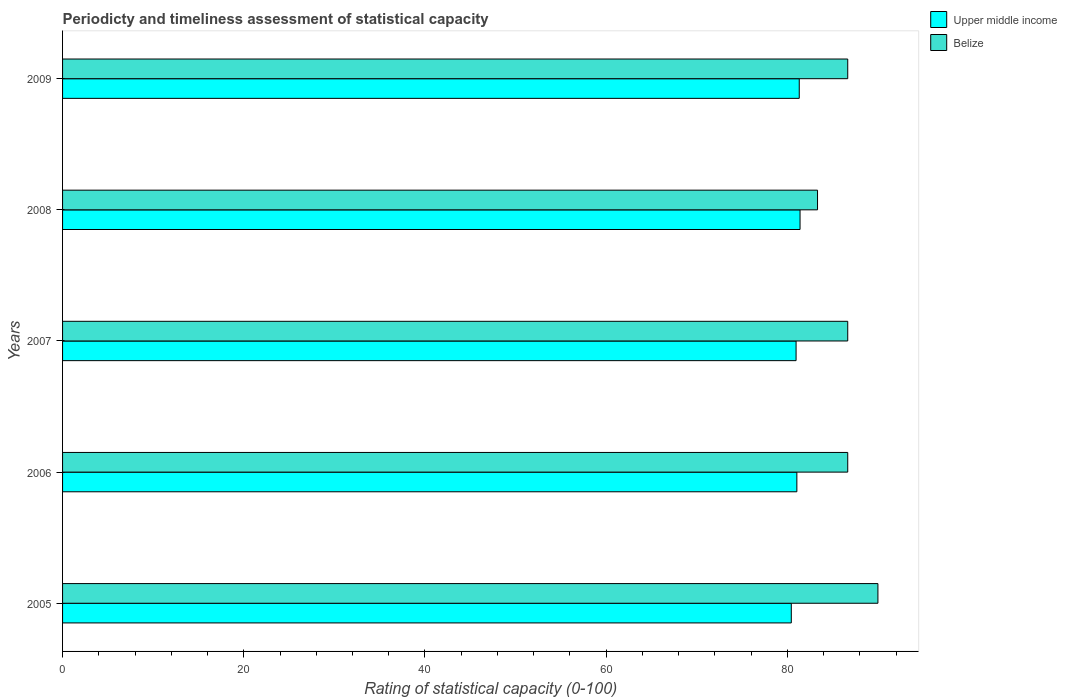How many different coloured bars are there?
Provide a succinct answer. 2. Are the number of bars per tick equal to the number of legend labels?
Offer a terse response. Yes. What is the rating of statistical capacity in Belize in 2009?
Make the answer very short. 86.67. Across all years, what is the minimum rating of statistical capacity in Belize?
Keep it short and to the point. 83.33. In which year was the rating of statistical capacity in Upper middle income maximum?
Provide a short and direct response. 2008. In which year was the rating of statistical capacity in Belize minimum?
Your response must be concise. 2008. What is the total rating of statistical capacity in Belize in the graph?
Ensure brevity in your answer.  433.33. What is the difference between the rating of statistical capacity in Belize in 2008 and that in 2009?
Your answer should be compact. -3.33. What is the difference between the rating of statistical capacity in Belize in 2005 and the rating of statistical capacity in Upper middle income in 2008?
Provide a succinct answer. 8.6. What is the average rating of statistical capacity in Upper middle income per year?
Make the answer very short. 81.03. In the year 2006, what is the difference between the rating of statistical capacity in Belize and rating of statistical capacity in Upper middle income?
Give a very brief answer. 5.61. What is the ratio of the rating of statistical capacity in Upper middle income in 2005 to that in 2006?
Provide a succinct answer. 0.99. Is the rating of statistical capacity in Upper middle income in 2005 less than that in 2007?
Provide a short and direct response. Yes. What is the difference between the highest and the second highest rating of statistical capacity in Belize?
Your response must be concise. 3.33. What is the difference between the highest and the lowest rating of statistical capacity in Belize?
Offer a terse response. 6.67. In how many years, is the rating of statistical capacity in Upper middle income greater than the average rating of statistical capacity in Upper middle income taken over all years?
Offer a very short reply. 3. Is the sum of the rating of statistical capacity in Upper middle income in 2007 and 2008 greater than the maximum rating of statistical capacity in Belize across all years?
Keep it short and to the point. Yes. What does the 1st bar from the top in 2008 represents?
Offer a very short reply. Belize. What does the 1st bar from the bottom in 2009 represents?
Provide a succinct answer. Upper middle income. How many years are there in the graph?
Offer a very short reply. 5. What is the difference between two consecutive major ticks on the X-axis?
Your response must be concise. 20. Are the values on the major ticks of X-axis written in scientific E-notation?
Offer a terse response. No. How many legend labels are there?
Keep it short and to the point. 2. How are the legend labels stacked?
Make the answer very short. Vertical. What is the title of the graph?
Give a very brief answer. Periodicty and timeliness assessment of statistical capacity. Does "St. Martin (French part)" appear as one of the legend labels in the graph?
Offer a very short reply. No. What is the label or title of the X-axis?
Your answer should be compact. Rating of statistical capacity (0-100). What is the label or title of the Y-axis?
Offer a terse response. Years. What is the Rating of statistical capacity (0-100) of Upper middle income in 2005?
Provide a short and direct response. 80.44. What is the Rating of statistical capacity (0-100) in Belize in 2005?
Offer a very short reply. 90. What is the Rating of statistical capacity (0-100) of Upper middle income in 2006?
Ensure brevity in your answer.  81.05. What is the Rating of statistical capacity (0-100) of Belize in 2006?
Your response must be concise. 86.67. What is the Rating of statistical capacity (0-100) of Upper middle income in 2007?
Offer a very short reply. 80.96. What is the Rating of statistical capacity (0-100) of Belize in 2007?
Offer a very short reply. 86.67. What is the Rating of statistical capacity (0-100) of Upper middle income in 2008?
Give a very brief answer. 81.4. What is the Rating of statistical capacity (0-100) of Belize in 2008?
Provide a short and direct response. 83.33. What is the Rating of statistical capacity (0-100) in Upper middle income in 2009?
Offer a terse response. 81.32. What is the Rating of statistical capacity (0-100) in Belize in 2009?
Make the answer very short. 86.67. Across all years, what is the maximum Rating of statistical capacity (0-100) of Upper middle income?
Ensure brevity in your answer.  81.4. Across all years, what is the maximum Rating of statistical capacity (0-100) of Belize?
Provide a succinct answer. 90. Across all years, what is the minimum Rating of statistical capacity (0-100) of Upper middle income?
Your answer should be compact. 80.44. Across all years, what is the minimum Rating of statistical capacity (0-100) of Belize?
Keep it short and to the point. 83.33. What is the total Rating of statistical capacity (0-100) in Upper middle income in the graph?
Your response must be concise. 405.17. What is the total Rating of statistical capacity (0-100) of Belize in the graph?
Your answer should be compact. 433.33. What is the difference between the Rating of statistical capacity (0-100) of Upper middle income in 2005 and that in 2006?
Keep it short and to the point. -0.61. What is the difference between the Rating of statistical capacity (0-100) in Belize in 2005 and that in 2006?
Provide a succinct answer. 3.33. What is the difference between the Rating of statistical capacity (0-100) of Upper middle income in 2005 and that in 2007?
Ensure brevity in your answer.  -0.53. What is the difference between the Rating of statistical capacity (0-100) in Belize in 2005 and that in 2007?
Your answer should be very brief. 3.33. What is the difference between the Rating of statistical capacity (0-100) of Upper middle income in 2005 and that in 2008?
Offer a very short reply. -0.96. What is the difference between the Rating of statistical capacity (0-100) of Upper middle income in 2005 and that in 2009?
Ensure brevity in your answer.  -0.88. What is the difference between the Rating of statistical capacity (0-100) of Upper middle income in 2006 and that in 2007?
Give a very brief answer. 0.09. What is the difference between the Rating of statistical capacity (0-100) of Upper middle income in 2006 and that in 2008?
Your answer should be very brief. -0.35. What is the difference between the Rating of statistical capacity (0-100) of Upper middle income in 2006 and that in 2009?
Provide a short and direct response. -0.26. What is the difference between the Rating of statistical capacity (0-100) of Belize in 2006 and that in 2009?
Keep it short and to the point. 0. What is the difference between the Rating of statistical capacity (0-100) in Upper middle income in 2007 and that in 2008?
Provide a short and direct response. -0.44. What is the difference between the Rating of statistical capacity (0-100) of Upper middle income in 2007 and that in 2009?
Provide a succinct answer. -0.35. What is the difference between the Rating of statistical capacity (0-100) of Belize in 2007 and that in 2009?
Your response must be concise. 0. What is the difference between the Rating of statistical capacity (0-100) in Upper middle income in 2008 and that in 2009?
Your answer should be compact. 0.09. What is the difference between the Rating of statistical capacity (0-100) of Belize in 2008 and that in 2009?
Offer a terse response. -3.33. What is the difference between the Rating of statistical capacity (0-100) of Upper middle income in 2005 and the Rating of statistical capacity (0-100) of Belize in 2006?
Provide a succinct answer. -6.23. What is the difference between the Rating of statistical capacity (0-100) in Upper middle income in 2005 and the Rating of statistical capacity (0-100) in Belize in 2007?
Provide a short and direct response. -6.23. What is the difference between the Rating of statistical capacity (0-100) in Upper middle income in 2005 and the Rating of statistical capacity (0-100) in Belize in 2008?
Provide a succinct answer. -2.89. What is the difference between the Rating of statistical capacity (0-100) in Upper middle income in 2005 and the Rating of statistical capacity (0-100) in Belize in 2009?
Offer a terse response. -6.23. What is the difference between the Rating of statistical capacity (0-100) of Upper middle income in 2006 and the Rating of statistical capacity (0-100) of Belize in 2007?
Give a very brief answer. -5.61. What is the difference between the Rating of statistical capacity (0-100) in Upper middle income in 2006 and the Rating of statistical capacity (0-100) in Belize in 2008?
Provide a short and direct response. -2.28. What is the difference between the Rating of statistical capacity (0-100) of Upper middle income in 2006 and the Rating of statistical capacity (0-100) of Belize in 2009?
Offer a terse response. -5.61. What is the difference between the Rating of statistical capacity (0-100) in Upper middle income in 2007 and the Rating of statistical capacity (0-100) in Belize in 2008?
Provide a short and direct response. -2.37. What is the difference between the Rating of statistical capacity (0-100) in Upper middle income in 2007 and the Rating of statistical capacity (0-100) in Belize in 2009?
Your answer should be very brief. -5.7. What is the difference between the Rating of statistical capacity (0-100) of Upper middle income in 2008 and the Rating of statistical capacity (0-100) of Belize in 2009?
Make the answer very short. -5.26. What is the average Rating of statistical capacity (0-100) of Upper middle income per year?
Offer a terse response. 81.03. What is the average Rating of statistical capacity (0-100) in Belize per year?
Ensure brevity in your answer.  86.67. In the year 2005, what is the difference between the Rating of statistical capacity (0-100) in Upper middle income and Rating of statistical capacity (0-100) in Belize?
Your answer should be very brief. -9.56. In the year 2006, what is the difference between the Rating of statistical capacity (0-100) of Upper middle income and Rating of statistical capacity (0-100) of Belize?
Offer a very short reply. -5.61. In the year 2007, what is the difference between the Rating of statistical capacity (0-100) in Upper middle income and Rating of statistical capacity (0-100) in Belize?
Ensure brevity in your answer.  -5.7. In the year 2008, what is the difference between the Rating of statistical capacity (0-100) of Upper middle income and Rating of statistical capacity (0-100) of Belize?
Make the answer very short. -1.93. In the year 2009, what is the difference between the Rating of statistical capacity (0-100) of Upper middle income and Rating of statistical capacity (0-100) of Belize?
Ensure brevity in your answer.  -5.35. What is the ratio of the Rating of statistical capacity (0-100) in Upper middle income in 2005 to that in 2007?
Offer a terse response. 0.99. What is the ratio of the Rating of statistical capacity (0-100) of Upper middle income in 2005 to that in 2008?
Keep it short and to the point. 0.99. What is the ratio of the Rating of statistical capacity (0-100) in Belize in 2005 to that in 2009?
Offer a terse response. 1.04. What is the ratio of the Rating of statistical capacity (0-100) of Belize in 2006 to that in 2008?
Ensure brevity in your answer.  1.04. What is the ratio of the Rating of statistical capacity (0-100) of Upper middle income in 2006 to that in 2009?
Give a very brief answer. 1. What is the ratio of the Rating of statistical capacity (0-100) in Upper middle income in 2007 to that in 2008?
Offer a terse response. 0.99. What is the ratio of the Rating of statistical capacity (0-100) in Upper middle income in 2007 to that in 2009?
Give a very brief answer. 1. What is the ratio of the Rating of statistical capacity (0-100) in Belize in 2007 to that in 2009?
Your response must be concise. 1. What is the ratio of the Rating of statistical capacity (0-100) of Upper middle income in 2008 to that in 2009?
Make the answer very short. 1. What is the ratio of the Rating of statistical capacity (0-100) in Belize in 2008 to that in 2009?
Offer a terse response. 0.96. What is the difference between the highest and the second highest Rating of statistical capacity (0-100) of Upper middle income?
Provide a short and direct response. 0.09. What is the difference between the highest and the lowest Rating of statistical capacity (0-100) of Upper middle income?
Provide a succinct answer. 0.96. 